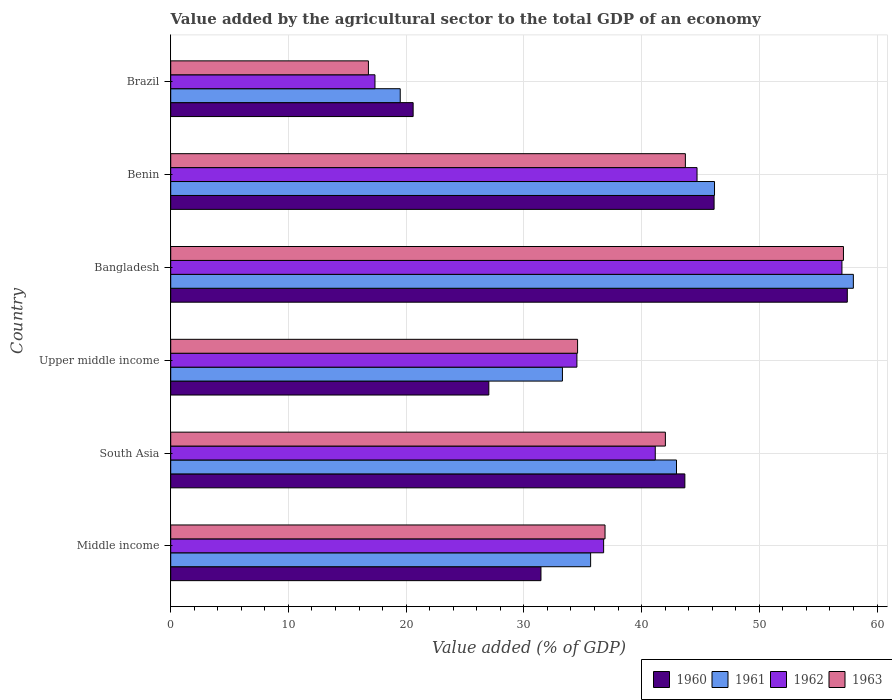How many groups of bars are there?
Offer a terse response. 6. How many bars are there on the 3rd tick from the top?
Your answer should be compact. 4. How many bars are there on the 6th tick from the bottom?
Your answer should be compact. 4. What is the label of the 2nd group of bars from the top?
Provide a short and direct response. Benin. What is the value added by the agricultural sector to the total GDP in 1963 in Upper middle income?
Your response must be concise. 34.56. Across all countries, what is the maximum value added by the agricultural sector to the total GDP in 1961?
Your answer should be very brief. 57.99. Across all countries, what is the minimum value added by the agricultural sector to the total GDP in 1963?
Ensure brevity in your answer.  16.79. What is the total value added by the agricultural sector to the total GDP in 1960 in the graph?
Your answer should be compact. 226.37. What is the difference between the value added by the agricultural sector to the total GDP in 1963 in Benin and that in Upper middle income?
Your answer should be compact. 9.16. What is the difference between the value added by the agricultural sector to the total GDP in 1960 in Benin and the value added by the agricultural sector to the total GDP in 1962 in Upper middle income?
Provide a short and direct response. 11.65. What is the average value added by the agricultural sector to the total GDP in 1961 per country?
Make the answer very short. 39.26. What is the difference between the value added by the agricultural sector to the total GDP in 1960 and value added by the agricultural sector to the total GDP in 1961 in Middle income?
Ensure brevity in your answer.  -4.22. What is the ratio of the value added by the agricultural sector to the total GDP in 1960 in Bangladesh to that in Upper middle income?
Give a very brief answer. 2.13. Is the value added by the agricultural sector to the total GDP in 1962 in Middle income less than that in Upper middle income?
Provide a succinct answer. No. Is the difference between the value added by the agricultural sector to the total GDP in 1960 in Benin and Brazil greater than the difference between the value added by the agricultural sector to the total GDP in 1961 in Benin and Brazil?
Provide a short and direct response. No. What is the difference between the highest and the second highest value added by the agricultural sector to the total GDP in 1961?
Your answer should be very brief. 11.79. What is the difference between the highest and the lowest value added by the agricultural sector to the total GDP in 1961?
Provide a short and direct response. 38.49. Is the sum of the value added by the agricultural sector to the total GDP in 1961 in Middle income and Upper middle income greater than the maximum value added by the agricultural sector to the total GDP in 1962 across all countries?
Offer a very short reply. Yes. What does the 3rd bar from the top in Middle income represents?
Make the answer very short. 1961. How many bars are there?
Your answer should be very brief. 24. How many countries are there in the graph?
Your response must be concise. 6. Are the values on the major ticks of X-axis written in scientific E-notation?
Offer a terse response. No. Does the graph contain grids?
Your answer should be compact. Yes. What is the title of the graph?
Make the answer very short. Value added by the agricultural sector to the total GDP of an economy. What is the label or title of the X-axis?
Offer a terse response. Value added (% of GDP). What is the Value added (% of GDP) in 1960 in Middle income?
Make the answer very short. 31.45. What is the Value added (% of GDP) in 1961 in Middle income?
Provide a short and direct response. 35.67. What is the Value added (% of GDP) in 1962 in Middle income?
Provide a succinct answer. 36.77. What is the Value added (% of GDP) of 1963 in Middle income?
Your response must be concise. 36.89. What is the Value added (% of GDP) of 1960 in South Asia?
Keep it short and to the point. 43.68. What is the Value added (% of GDP) of 1961 in South Asia?
Offer a terse response. 42.96. What is the Value added (% of GDP) of 1962 in South Asia?
Your answer should be compact. 41.16. What is the Value added (% of GDP) in 1963 in South Asia?
Your answer should be very brief. 42.02. What is the Value added (% of GDP) in 1960 in Upper middle income?
Your answer should be compact. 27.02. What is the Value added (% of GDP) in 1961 in Upper middle income?
Make the answer very short. 33.27. What is the Value added (% of GDP) of 1962 in Upper middle income?
Your answer should be very brief. 34.5. What is the Value added (% of GDP) of 1963 in Upper middle income?
Provide a succinct answer. 34.56. What is the Value added (% of GDP) in 1960 in Bangladesh?
Offer a very short reply. 57.47. What is the Value added (% of GDP) of 1961 in Bangladesh?
Offer a terse response. 57.99. What is the Value added (% of GDP) in 1962 in Bangladesh?
Give a very brief answer. 57.02. What is the Value added (% of GDP) of 1963 in Bangladesh?
Offer a very short reply. 57.15. What is the Value added (% of GDP) of 1960 in Benin?
Make the answer very short. 46.16. What is the Value added (% of GDP) of 1961 in Benin?
Make the answer very short. 46.19. What is the Value added (% of GDP) of 1962 in Benin?
Your answer should be compact. 44.71. What is the Value added (% of GDP) in 1963 in Benin?
Give a very brief answer. 43.72. What is the Value added (% of GDP) in 1960 in Brazil?
Your response must be concise. 20.59. What is the Value added (% of GDP) in 1961 in Brazil?
Offer a terse response. 19.5. What is the Value added (% of GDP) of 1962 in Brazil?
Keep it short and to the point. 17.35. What is the Value added (% of GDP) in 1963 in Brazil?
Ensure brevity in your answer.  16.79. Across all countries, what is the maximum Value added (% of GDP) of 1960?
Keep it short and to the point. 57.47. Across all countries, what is the maximum Value added (% of GDP) of 1961?
Your answer should be compact. 57.99. Across all countries, what is the maximum Value added (% of GDP) of 1962?
Offer a very short reply. 57.02. Across all countries, what is the maximum Value added (% of GDP) in 1963?
Ensure brevity in your answer.  57.15. Across all countries, what is the minimum Value added (% of GDP) in 1960?
Your answer should be compact. 20.59. Across all countries, what is the minimum Value added (% of GDP) in 1961?
Offer a terse response. 19.5. Across all countries, what is the minimum Value added (% of GDP) in 1962?
Your answer should be very brief. 17.35. Across all countries, what is the minimum Value added (% of GDP) in 1963?
Make the answer very short. 16.79. What is the total Value added (% of GDP) in 1960 in the graph?
Keep it short and to the point. 226.37. What is the total Value added (% of GDP) of 1961 in the graph?
Offer a terse response. 235.59. What is the total Value added (% of GDP) in 1962 in the graph?
Offer a terse response. 231.52. What is the total Value added (% of GDP) in 1963 in the graph?
Provide a succinct answer. 231.13. What is the difference between the Value added (% of GDP) in 1960 in Middle income and that in South Asia?
Offer a very short reply. -12.22. What is the difference between the Value added (% of GDP) of 1961 in Middle income and that in South Asia?
Provide a succinct answer. -7.29. What is the difference between the Value added (% of GDP) in 1962 in Middle income and that in South Asia?
Offer a very short reply. -4.39. What is the difference between the Value added (% of GDP) in 1963 in Middle income and that in South Asia?
Offer a terse response. -5.13. What is the difference between the Value added (% of GDP) in 1960 in Middle income and that in Upper middle income?
Your response must be concise. 4.43. What is the difference between the Value added (% of GDP) in 1961 in Middle income and that in Upper middle income?
Provide a short and direct response. 2.4. What is the difference between the Value added (% of GDP) in 1962 in Middle income and that in Upper middle income?
Provide a short and direct response. 2.27. What is the difference between the Value added (% of GDP) in 1963 in Middle income and that in Upper middle income?
Your answer should be compact. 2.33. What is the difference between the Value added (% of GDP) of 1960 in Middle income and that in Bangladesh?
Your answer should be very brief. -26.02. What is the difference between the Value added (% of GDP) of 1961 in Middle income and that in Bangladesh?
Your answer should be compact. -22.32. What is the difference between the Value added (% of GDP) of 1962 in Middle income and that in Bangladesh?
Provide a short and direct response. -20.24. What is the difference between the Value added (% of GDP) of 1963 in Middle income and that in Bangladesh?
Provide a succinct answer. -20.25. What is the difference between the Value added (% of GDP) of 1960 in Middle income and that in Benin?
Provide a succinct answer. -14.71. What is the difference between the Value added (% of GDP) of 1961 in Middle income and that in Benin?
Offer a terse response. -10.52. What is the difference between the Value added (% of GDP) in 1962 in Middle income and that in Benin?
Offer a very short reply. -7.94. What is the difference between the Value added (% of GDP) of 1963 in Middle income and that in Benin?
Make the answer very short. -6.82. What is the difference between the Value added (% of GDP) in 1960 in Middle income and that in Brazil?
Make the answer very short. 10.86. What is the difference between the Value added (% of GDP) in 1961 in Middle income and that in Brazil?
Offer a very short reply. 16.17. What is the difference between the Value added (% of GDP) in 1962 in Middle income and that in Brazil?
Provide a succinct answer. 19.42. What is the difference between the Value added (% of GDP) in 1963 in Middle income and that in Brazil?
Give a very brief answer. 20.1. What is the difference between the Value added (% of GDP) in 1960 in South Asia and that in Upper middle income?
Offer a terse response. 16.65. What is the difference between the Value added (% of GDP) in 1961 in South Asia and that in Upper middle income?
Make the answer very short. 9.69. What is the difference between the Value added (% of GDP) of 1962 in South Asia and that in Upper middle income?
Offer a terse response. 6.66. What is the difference between the Value added (% of GDP) of 1963 in South Asia and that in Upper middle income?
Give a very brief answer. 7.46. What is the difference between the Value added (% of GDP) of 1960 in South Asia and that in Bangladesh?
Offer a very short reply. -13.8. What is the difference between the Value added (% of GDP) of 1961 in South Asia and that in Bangladesh?
Keep it short and to the point. -15.02. What is the difference between the Value added (% of GDP) in 1962 in South Asia and that in Bangladesh?
Offer a terse response. -15.86. What is the difference between the Value added (% of GDP) of 1963 in South Asia and that in Bangladesh?
Provide a short and direct response. -15.13. What is the difference between the Value added (% of GDP) of 1960 in South Asia and that in Benin?
Your answer should be compact. -2.48. What is the difference between the Value added (% of GDP) of 1961 in South Asia and that in Benin?
Ensure brevity in your answer.  -3.23. What is the difference between the Value added (% of GDP) in 1962 in South Asia and that in Benin?
Offer a terse response. -3.55. What is the difference between the Value added (% of GDP) of 1963 in South Asia and that in Benin?
Offer a terse response. -1.7. What is the difference between the Value added (% of GDP) in 1960 in South Asia and that in Brazil?
Offer a terse response. 23.08. What is the difference between the Value added (% of GDP) in 1961 in South Asia and that in Brazil?
Give a very brief answer. 23.47. What is the difference between the Value added (% of GDP) in 1962 in South Asia and that in Brazil?
Give a very brief answer. 23.81. What is the difference between the Value added (% of GDP) in 1963 in South Asia and that in Brazil?
Provide a short and direct response. 25.23. What is the difference between the Value added (% of GDP) of 1960 in Upper middle income and that in Bangladesh?
Your answer should be very brief. -30.45. What is the difference between the Value added (% of GDP) of 1961 in Upper middle income and that in Bangladesh?
Provide a short and direct response. -24.71. What is the difference between the Value added (% of GDP) of 1962 in Upper middle income and that in Bangladesh?
Provide a short and direct response. -22.51. What is the difference between the Value added (% of GDP) in 1963 in Upper middle income and that in Bangladesh?
Your answer should be compact. -22.59. What is the difference between the Value added (% of GDP) of 1960 in Upper middle income and that in Benin?
Offer a very short reply. -19.14. What is the difference between the Value added (% of GDP) in 1961 in Upper middle income and that in Benin?
Provide a short and direct response. -12.92. What is the difference between the Value added (% of GDP) of 1962 in Upper middle income and that in Benin?
Offer a very short reply. -10.21. What is the difference between the Value added (% of GDP) of 1963 in Upper middle income and that in Benin?
Offer a very short reply. -9.16. What is the difference between the Value added (% of GDP) in 1960 in Upper middle income and that in Brazil?
Your response must be concise. 6.43. What is the difference between the Value added (% of GDP) in 1961 in Upper middle income and that in Brazil?
Provide a short and direct response. 13.78. What is the difference between the Value added (% of GDP) in 1962 in Upper middle income and that in Brazil?
Provide a succinct answer. 17.15. What is the difference between the Value added (% of GDP) of 1963 in Upper middle income and that in Brazil?
Offer a terse response. 17.77. What is the difference between the Value added (% of GDP) of 1960 in Bangladesh and that in Benin?
Offer a very short reply. 11.32. What is the difference between the Value added (% of GDP) of 1961 in Bangladesh and that in Benin?
Ensure brevity in your answer.  11.79. What is the difference between the Value added (% of GDP) of 1962 in Bangladesh and that in Benin?
Ensure brevity in your answer.  12.31. What is the difference between the Value added (% of GDP) in 1963 in Bangladesh and that in Benin?
Your response must be concise. 13.43. What is the difference between the Value added (% of GDP) in 1960 in Bangladesh and that in Brazil?
Make the answer very short. 36.88. What is the difference between the Value added (% of GDP) of 1961 in Bangladesh and that in Brazil?
Your response must be concise. 38.49. What is the difference between the Value added (% of GDP) in 1962 in Bangladesh and that in Brazil?
Provide a short and direct response. 39.67. What is the difference between the Value added (% of GDP) of 1963 in Bangladesh and that in Brazil?
Your answer should be very brief. 40.35. What is the difference between the Value added (% of GDP) of 1960 in Benin and that in Brazil?
Provide a succinct answer. 25.56. What is the difference between the Value added (% of GDP) in 1961 in Benin and that in Brazil?
Offer a very short reply. 26.7. What is the difference between the Value added (% of GDP) of 1962 in Benin and that in Brazil?
Your answer should be very brief. 27.36. What is the difference between the Value added (% of GDP) in 1963 in Benin and that in Brazil?
Your answer should be compact. 26.92. What is the difference between the Value added (% of GDP) of 1960 in Middle income and the Value added (% of GDP) of 1961 in South Asia?
Ensure brevity in your answer.  -11.51. What is the difference between the Value added (% of GDP) in 1960 in Middle income and the Value added (% of GDP) in 1962 in South Asia?
Provide a succinct answer. -9.71. What is the difference between the Value added (% of GDP) of 1960 in Middle income and the Value added (% of GDP) of 1963 in South Asia?
Make the answer very short. -10.57. What is the difference between the Value added (% of GDP) in 1961 in Middle income and the Value added (% of GDP) in 1962 in South Asia?
Make the answer very short. -5.49. What is the difference between the Value added (% of GDP) in 1961 in Middle income and the Value added (% of GDP) in 1963 in South Asia?
Make the answer very short. -6.35. What is the difference between the Value added (% of GDP) in 1962 in Middle income and the Value added (% of GDP) in 1963 in South Asia?
Offer a terse response. -5.25. What is the difference between the Value added (% of GDP) in 1960 in Middle income and the Value added (% of GDP) in 1961 in Upper middle income?
Your answer should be compact. -1.82. What is the difference between the Value added (% of GDP) in 1960 in Middle income and the Value added (% of GDP) in 1962 in Upper middle income?
Provide a short and direct response. -3.05. What is the difference between the Value added (% of GDP) in 1960 in Middle income and the Value added (% of GDP) in 1963 in Upper middle income?
Your answer should be very brief. -3.11. What is the difference between the Value added (% of GDP) of 1961 in Middle income and the Value added (% of GDP) of 1962 in Upper middle income?
Provide a short and direct response. 1.17. What is the difference between the Value added (% of GDP) in 1961 in Middle income and the Value added (% of GDP) in 1963 in Upper middle income?
Keep it short and to the point. 1.11. What is the difference between the Value added (% of GDP) of 1962 in Middle income and the Value added (% of GDP) of 1963 in Upper middle income?
Make the answer very short. 2.21. What is the difference between the Value added (% of GDP) in 1960 in Middle income and the Value added (% of GDP) in 1961 in Bangladesh?
Offer a terse response. -26.54. What is the difference between the Value added (% of GDP) of 1960 in Middle income and the Value added (% of GDP) of 1962 in Bangladesh?
Your answer should be compact. -25.57. What is the difference between the Value added (% of GDP) in 1960 in Middle income and the Value added (% of GDP) in 1963 in Bangladesh?
Your answer should be compact. -25.7. What is the difference between the Value added (% of GDP) of 1961 in Middle income and the Value added (% of GDP) of 1962 in Bangladesh?
Your answer should be compact. -21.35. What is the difference between the Value added (% of GDP) of 1961 in Middle income and the Value added (% of GDP) of 1963 in Bangladesh?
Offer a terse response. -21.48. What is the difference between the Value added (% of GDP) in 1962 in Middle income and the Value added (% of GDP) in 1963 in Bangladesh?
Your answer should be compact. -20.37. What is the difference between the Value added (% of GDP) of 1960 in Middle income and the Value added (% of GDP) of 1961 in Benin?
Keep it short and to the point. -14.74. What is the difference between the Value added (% of GDP) of 1960 in Middle income and the Value added (% of GDP) of 1962 in Benin?
Provide a short and direct response. -13.26. What is the difference between the Value added (% of GDP) in 1960 in Middle income and the Value added (% of GDP) in 1963 in Benin?
Provide a short and direct response. -12.27. What is the difference between the Value added (% of GDP) in 1961 in Middle income and the Value added (% of GDP) in 1962 in Benin?
Offer a very short reply. -9.04. What is the difference between the Value added (% of GDP) of 1961 in Middle income and the Value added (% of GDP) of 1963 in Benin?
Offer a terse response. -8.05. What is the difference between the Value added (% of GDP) of 1962 in Middle income and the Value added (% of GDP) of 1963 in Benin?
Provide a short and direct response. -6.94. What is the difference between the Value added (% of GDP) of 1960 in Middle income and the Value added (% of GDP) of 1961 in Brazil?
Your answer should be compact. 11.95. What is the difference between the Value added (% of GDP) in 1960 in Middle income and the Value added (% of GDP) in 1962 in Brazil?
Your answer should be very brief. 14.1. What is the difference between the Value added (% of GDP) in 1960 in Middle income and the Value added (% of GDP) in 1963 in Brazil?
Ensure brevity in your answer.  14.66. What is the difference between the Value added (% of GDP) in 1961 in Middle income and the Value added (% of GDP) in 1962 in Brazil?
Your response must be concise. 18.32. What is the difference between the Value added (% of GDP) in 1961 in Middle income and the Value added (% of GDP) in 1963 in Brazil?
Give a very brief answer. 18.88. What is the difference between the Value added (% of GDP) of 1962 in Middle income and the Value added (% of GDP) of 1963 in Brazil?
Your answer should be compact. 19.98. What is the difference between the Value added (% of GDP) in 1960 in South Asia and the Value added (% of GDP) in 1961 in Upper middle income?
Offer a very short reply. 10.4. What is the difference between the Value added (% of GDP) of 1960 in South Asia and the Value added (% of GDP) of 1962 in Upper middle income?
Keep it short and to the point. 9.17. What is the difference between the Value added (% of GDP) of 1960 in South Asia and the Value added (% of GDP) of 1963 in Upper middle income?
Your answer should be very brief. 9.11. What is the difference between the Value added (% of GDP) in 1961 in South Asia and the Value added (% of GDP) in 1962 in Upper middle income?
Ensure brevity in your answer.  8.46. What is the difference between the Value added (% of GDP) in 1961 in South Asia and the Value added (% of GDP) in 1963 in Upper middle income?
Offer a very short reply. 8.4. What is the difference between the Value added (% of GDP) of 1962 in South Asia and the Value added (% of GDP) of 1963 in Upper middle income?
Ensure brevity in your answer.  6.6. What is the difference between the Value added (% of GDP) in 1960 in South Asia and the Value added (% of GDP) in 1961 in Bangladesh?
Make the answer very short. -14.31. What is the difference between the Value added (% of GDP) of 1960 in South Asia and the Value added (% of GDP) of 1962 in Bangladesh?
Provide a short and direct response. -13.34. What is the difference between the Value added (% of GDP) in 1960 in South Asia and the Value added (% of GDP) in 1963 in Bangladesh?
Your response must be concise. -13.47. What is the difference between the Value added (% of GDP) of 1961 in South Asia and the Value added (% of GDP) of 1962 in Bangladesh?
Keep it short and to the point. -14.05. What is the difference between the Value added (% of GDP) in 1961 in South Asia and the Value added (% of GDP) in 1963 in Bangladesh?
Make the answer very short. -14.18. What is the difference between the Value added (% of GDP) of 1962 in South Asia and the Value added (% of GDP) of 1963 in Bangladesh?
Give a very brief answer. -15.99. What is the difference between the Value added (% of GDP) of 1960 in South Asia and the Value added (% of GDP) of 1961 in Benin?
Offer a terse response. -2.52. What is the difference between the Value added (% of GDP) in 1960 in South Asia and the Value added (% of GDP) in 1962 in Benin?
Offer a very short reply. -1.03. What is the difference between the Value added (% of GDP) in 1960 in South Asia and the Value added (% of GDP) in 1963 in Benin?
Ensure brevity in your answer.  -0.04. What is the difference between the Value added (% of GDP) of 1961 in South Asia and the Value added (% of GDP) of 1962 in Benin?
Give a very brief answer. -1.74. What is the difference between the Value added (% of GDP) in 1961 in South Asia and the Value added (% of GDP) in 1963 in Benin?
Your answer should be very brief. -0.75. What is the difference between the Value added (% of GDP) in 1962 in South Asia and the Value added (% of GDP) in 1963 in Benin?
Give a very brief answer. -2.56. What is the difference between the Value added (% of GDP) of 1960 in South Asia and the Value added (% of GDP) of 1961 in Brazil?
Your answer should be compact. 24.18. What is the difference between the Value added (% of GDP) in 1960 in South Asia and the Value added (% of GDP) in 1962 in Brazil?
Your response must be concise. 26.32. What is the difference between the Value added (% of GDP) of 1960 in South Asia and the Value added (% of GDP) of 1963 in Brazil?
Your response must be concise. 26.88. What is the difference between the Value added (% of GDP) of 1961 in South Asia and the Value added (% of GDP) of 1962 in Brazil?
Your answer should be very brief. 25.61. What is the difference between the Value added (% of GDP) in 1961 in South Asia and the Value added (% of GDP) in 1963 in Brazil?
Make the answer very short. 26.17. What is the difference between the Value added (% of GDP) in 1962 in South Asia and the Value added (% of GDP) in 1963 in Brazil?
Offer a terse response. 24.37. What is the difference between the Value added (% of GDP) of 1960 in Upper middle income and the Value added (% of GDP) of 1961 in Bangladesh?
Your response must be concise. -30.97. What is the difference between the Value added (% of GDP) in 1960 in Upper middle income and the Value added (% of GDP) in 1962 in Bangladesh?
Ensure brevity in your answer.  -30. What is the difference between the Value added (% of GDP) in 1960 in Upper middle income and the Value added (% of GDP) in 1963 in Bangladesh?
Provide a short and direct response. -30.12. What is the difference between the Value added (% of GDP) of 1961 in Upper middle income and the Value added (% of GDP) of 1962 in Bangladesh?
Give a very brief answer. -23.74. What is the difference between the Value added (% of GDP) of 1961 in Upper middle income and the Value added (% of GDP) of 1963 in Bangladesh?
Make the answer very short. -23.87. What is the difference between the Value added (% of GDP) in 1962 in Upper middle income and the Value added (% of GDP) in 1963 in Bangladesh?
Ensure brevity in your answer.  -22.64. What is the difference between the Value added (% of GDP) in 1960 in Upper middle income and the Value added (% of GDP) in 1961 in Benin?
Ensure brevity in your answer.  -19.17. What is the difference between the Value added (% of GDP) of 1960 in Upper middle income and the Value added (% of GDP) of 1962 in Benin?
Your answer should be compact. -17.69. What is the difference between the Value added (% of GDP) of 1960 in Upper middle income and the Value added (% of GDP) of 1963 in Benin?
Offer a terse response. -16.7. What is the difference between the Value added (% of GDP) in 1961 in Upper middle income and the Value added (% of GDP) in 1962 in Benin?
Offer a very short reply. -11.43. What is the difference between the Value added (% of GDP) of 1961 in Upper middle income and the Value added (% of GDP) of 1963 in Benin?
Offer a very short reply. -10.44. What is the difference between the Value added (% of GDP) of 1962 in Upper middle income and the Value added (% of GDP) of 1963 in Benin?
Give a very brief answer. -9.21. What is the difference between the Value added (% of GDP) in 1960 in Upper middle income and the Value added (% of GDP) in 1961 in Brazil?
Your response must be concise. 7.53. What is the difference between the Value added (% of GDP) in 1960 in Upper middle income and the Value added (% of GDP) in 1962 in Brazil?
Keep it short and to the point. 9.67. What is the difference between the Value added (% of GDP) in 1960 in Upper middle income and the Value added (% of GDP) in 1963 in Brazil?
Offer a very short reply. 10.23. What is the difference between the Value added (% of GDP) of 1961 in Upper middle income and the Value added (% of GDP) of 1962 in Brazil?
Your answer should be compact. 15.92. What is the difference between the Value added (% of GDP) in 1961 in Upper middle income and the Value added (% of GDP) in 1963 in Brazil?
Offer a very short reply. 16.48. What is the difference between the Value added (% of GDP) in 1962 in Upper middle income and the Value added (% of GDP) in 1963 in Brazil?
Offer a very short reply. 17.71. What is the difference between the Value added (% of GDP) of 1960 in Bangladesh and the Value added (% of GDP) of 1961 in Benin?
Provide a succinct answer. 11.28. What is the difference between the Value added (% of GDP) in 1960 in Bangladesh and the Value added (% of GDP) in 1962 in Benin?
Offer a very short reply. 12.77. What is the difference between the Value added (% of GDP) in 1960 in Bangladesh and the Value added (% of GDP) in 1963 in Benin?
Your response must be concise. 13.76. What is the difference between the Value added (% of GDP) of 1961 in Bangladesh and the Value added (% of GDP) of 1962 in Benin?
Ensure brevity in your answer.  13.28. What is the difference between the Value added (% of GDP) in 1961 in Bangladesh and the Value added (% of GDP) in 1963 in Benin?
Give a very brief answer. 14.27. What is the difference between the Value added (% of GDP) of 1962 in Bangladesh and the Value added (% of GDP) of 1963 in Benin?
Provide a succinct answer. 13.3. What is the difference between the Value added (% of GDP) of 1960 in Bangladesh and the Value added (% of GDP) of 1961 in Brazil?
Your answer should be very brief. 37.98. What is the difference between the Value added (% of GDP) of 1960 in Bangladesh and the Value added (% of GDP) of 1962 in Brazil?
Offer a very short reply. 40.12. What is the difference between the Value added (% of GDP) in 1960 in Bangladesh and the Value added (% of GDP) in 1963 in Brazil?
Give a very brief answer. 40.68. What is the difference between the Value added (% of GDP) of 1961 in Bangladesh and the Value added (% of GDP) of 1962 in Brazil?
Give a very brief answer. 40.64. What is the difference between the Value added (% of GDP) of 1961 in Bangladesh and the Value added (% of GDP) of 1963 in Brazil?
Keep it short and to the point. 41.19. What is the difference between the Value added (% of GDP) of 1962 in Bangladesh and the Value added (% of GDP) of 1963 in Brazil?
Your answer should be very brief. 40.22. What is the difference between the Value added (% of GDP) in 1960 in Benin and the Value added (% of GDP) in 1961 in Brazil?
Your answer should be compact. 26.66. What is the difference between the Value added (% of GDP) in 1960 in Benin and the Value added (% of GDP) in 1962 in Brazil?
Offer a very short reply. 28.81. What is the difference between the Value added (% of GDP) of 1960 in Benin and the Value added (% of GDP) of 1963 in Brazil?
Make the answer very short. 29.36. What is the difference between the Value added (% of GDP) in 1961 in Benin and the Value added (% of GDP) in 1962 in Brazil?
Offer a terse response. 28.84. What is the difference between the Value added (% of GDP) of 1961 in Benin and the Value added (% of GDP) of 1963 in Brazil?
Offer a terse response. 29.4. What is the difference between the Value added (% of GDP) of 1962 in Benin and the Value added (% of GDP) of 1963 in Brazil?
Your response must be concise. 27.92. What is the average Value added (% of GDP) of 1960 per country?
Offer a terse response. 37.73. What is the average Value added (% of GDP) of 1961 per country?
Offer a terse response. 39.26. What is the average Value added (% of GDP) of 1962 per country?
Ensure brevity in your answer.  38.59. What is the average Value added (% of GDP) in 1963 per country?
Ensure brevity in your answer.  38.52. What is the difference between the Value added (% of GDP) of 1960 and Value added (% of GDP) of 1961 in Middle income?
Ensure brevity in your answer.  -4.22. What is the difference between the Value added (% of GDP) of 1960 and Value added (% of GDP) of 1962 in Middle income?
Provide a short and direct response. -5.32. What is the difference between the Value added (% of GDP) of 1960 and Value added (% of GDP) of 1963 in Middle income?
Offer a very short reply. -5.44. What is the difference between the Value added (% of GDP) of 1961 and Value added (% of GDP) of 1962 in Middle income?
Ensure brevity in your answer.  -1.1. What is the difference between the Value added (% of GDP) in 1961 and Value added (% of GDP) in 1963 in Middle income?
Keep it short and to the point. -1.22. What is the difference between the Value added (% of GDP) in 1962 and Value added (% of GDP) in 1963 in Middle income?
Your answer should be very brief. -0.12. What is the difference between the Value added (% of GDP) in 1960 and Value added (% of GDP) in 1961 in South Asia?
Give a very brief answer. 0.71. What is the difference between the Value added (% of GDP) in 1960 and Value added (% of GDP) in 1962 in South Asia?
Provide a succinct answer. 2.52. What is the difference between the Value added (% of GDP) of 1960 and Value added (% of GDP) of 1963 in South Asia?
Make the answer very short. 1.66. What is the difference between the Value added (% of GDP) in 1961 and Value added (% of GDP) in 1962 in South Asia?
Provide a succinct answer. 1.8. What is the difference between the Value added (% of GDP) of 1961 and Value added (% of GDP) of 1963 in South Asia?
Provide a short and direct response. 0.95. What is the difference between the Value added (% of GDP) of 1962 and Value added (% of GDP) of 1963 in South Asia?
Keep it short and to the point. -0.86. What is the difference between the Value added (% of GDP) in 1960 and Value added (% of GDP) in 1961 in Upper middle income?
Make the answer very short. -6.25. What is the difference between the Value added (% of GDP) in 1960 and Value added (% of GDP) in 1962 in Upper middle income?
Offer a very short reply. -7.48. What is the difference between the Value added (% of GDP) of 1960 and Value added (% of GDP) of 1963 in Upper middle income?
Make the answer very short. -7.54. What is the difference between the Value added (% of GDP) in 1961 and Value added (% of GDP) in 1962 in Upper middle income?
Keep it short and to the point. -1.23. What is the difference between the Value added (% of GDP) of 1961 and Value added (% of GDP) of 1963 in Upper middle income?
Provide a succinct answer. -1.29. What is the difference between the Value added (% of GDP) in 1962 and Value added (% of GDP) in 1963 in Upper middle income?
Keep it short and to the point. -0.06. What is the difference between the Value added (% of GDP) in 1960 and Value added (% of GDP) in 1961 in Bangladesh?
Provide a succinct answer. -0.51. What is the difference between the Value added (% of GDP) of 1960 and Value added (% of GDP) of 1962 in Bangladesh?
Provide a succinct answer. 0.46. What is the difference between the Value added (% of GDP) in 1960 and Value added (% of GDP) in 1963 in Bangladesh?
Offer a terse response. 0.33. What is the difference between the Value added (% of GDP) of 1961 and Value added (% of GDP) of 1962 in Bangladesh?
Ensure brevity in your answer.  0.97. What is the difference between the Value added (% of GDP) in 1961 and Value added (% of GDP) in 1963 in Bangladesh?
Your answer should be compact. 0.84. What is the difference between the Value added (% of GDP) of 1962 and Value added (% of GDP) of 1963 in Bangladesh?
Make the answer very short. -0.13. What is the difference between the Value added (% of GDP) of 1960 and Value added (% of GDP) of 1961 in Benin?
Offer a very short reply. -0.04. What is the difference between the Value added (% of GDP) in 1960 and Value added (% of GDP) in 1962 in Benin?
Your answer should be compact. 1.45. What is the difference between the Value added (% of GDP) of 1960 and Value added (% of GDP) of 1963 in Benin?
Your answer should be very brief. 2.44. What is the difference between the Value added (% of GDP) in 1961 and Value added (% of GDP) in 1962 in Benin?
Provide a short and direct response. 1.48. What is the difference between the Value added (% of GDP) of 1961 and Value added (% of GDP) of 1963 in Benin?
Keep it short and to the point. 2.48. What is the difference between the Value added (% of GDP) of 1962 and Value added (% of GDP) of 1963 in Benin?
Provide a short and direct response. 0.99. What is the difference between the Value added (% of GDP) in 1960 and Value added (% of GDP) in 1961 in Brazil?
Provide a succinct answer. 1.1. What is the difference between the Value added (% of GDP) of 1960 and Value added (% of GDP) of 1962 in Brazil?
Your answer should be very brief. 3.24. What is the difference between the Value added (% of GDP) in 1960 and Value added (% of GDP) in 1963 in Brazil?
Make the answer very short. 3.8. What is the difference between the Value added (% of GDP) in 1961 and Value added (% of GDP) in 1962 in Brazil?
Provide a short and direct response. 2.15. What is the difference between the Value added (% of GDP) in 1961 and Value added (% of GDP) in 1963 in Brazil?
Your answer should be very brief. 2.7. What is the difference between the Value added (% of GDP) in 1962 and Value added (% of GDP) in 1963 in Brazil?
Offer a very short reply. 0.56. What is the ratio of the Value added (% of GDP) in 1960 in Middle income to that in South Asia?
Provide a succinct answer. 0.72. What is the ratio of the Value added (% of GDP) of 1961 in Middle income to that in South Asia?
Provide a succinct answer. 0.83. What is the ratio of the Value added (% of GDP) of 1962 in Middle income to that in South Asia?
Offer a very short reply. 0.89. What is the ratio of the Value added (% of GDP) in 1963 in Middle income to that in South Asia?
Give a very brief answer. 0.88. What is the ratio of the Value added (% of GDP) of 1960 in Middle income to that in Upper middle income?
Keep it short and to the point. 1.16. What is the ratio of the Value added (% of GDP) of 1961 in Middle income to that in Upper middle income?
Offer a terse response. 1.07. What is the ratio of the Value added (% of GDP) in 1962 in Middle income to that in Upper middle income?
Your response must be concise. 1.07. What is the ratio of the Value added (% of GDP) in 1963 in Middle income to that in Upper middle income?
Your response must be concise. 1.07. What is the ratio of the Value added (% of GDP) in 1960 in Middle income to that in Bangladesh?
Provide a succinct answer. 0.55. What is the ratio of the Value added (% of GDP) in 1961 in Middle income to that in Bangladesh?
Ensure brevity in your answer.  0.62. What is the ratio of the Value added (% of GDP) in 1962 in Middle income to that in Bangladesh?
Give a very brief answer. 0.64. What is the ratio of the Value added (% of GDP) of 1963 in Middle income to that in Bangladesh?
Keep it short and to the point. 0.65. What is the ratio of the Value added (% of GDP) in 1960 in Middle income to that in Benin?
Your response must be concise. 0.68. What is the ratio of the Value added (% of GDP) of 1961 in Middle income to that in Benin?
Provide a succinct answer. 0.77. What is the ratio of the Value added (% of GDP) of 1962 in Middle income to that in Benin?
Offer a terse response. 0.82. What is the ratio of the Value added (% of GDP) in 1963 in Middle income to that in Benin?
Provide a short and direct response. 0.84. What is the ratio of the Value added (% of GDP) of 1960 in Middle income to that in Brazil?
Ensure brevity in your answer.  1.53. What is the ratio of the Value added (% of GDP) of 1961 in Middle income to that in Brazil?
Provide a short and direct response. 1.83. What is the ratio of the Value added (% of GDP) in 1962 in Middle income to that in Brazil?
Keep it short and to the point. 2.12. What is the ratio of the Value added (% of GDP) in 1963 in Middle income to that in Brazil?
Offer a very short reply. 2.2. What is the ratio of the Value added (% of GDP) in 1960 in South Asia to that in Upper middle income?
Your answer should be very brief. 1.62. What is the ratio of the Value added (% of GDP) in 1961 in South Asia to that in Upper middle income?
Your answer should be very brief. 1.29. What is the ratio of the Value added (% of GDP) of 1962 in South Asia to that in Upper middle income?
Your response must be concise. 1.19. What is the ratio of the Value added (% of GDP) of 1963 in South Asia to that in Upper middle income?
Make the answer very short. 1.22. What is the ratio of the Value added (% of GDP) of 1960 in South Asia to that in Bangladesh?
Provide a short and direct response. 0.76. What is the ratio of the Value added (% of GDP) in 1961 in South Asia to that in Bangladesh?
Give a very brief answer. 0.74. What is the ratio of the Value added (% of GDP) of 1962 in South Asia to that in Bangladesh?
Your answer should be very brief. 0.72. What is the ratio of the Value added (% of GDP) in 1963 in South Asia to that in Bangladesh?
Your answer should be compact. 0.74. What is the ratio of the Value added (% of GDP) of 1960 in South Asia to that in Benin?
Your answer should be very brief. 0.95. What is the ratio of the Value added (% of GDP) in 1961 in South Asia to that in Benin?
Give a very brief answer. 0.93. What is the ratio of the Value added (% of GDP) of 1962 in South Asia to that in Benin?
Keep it short and to the point. 0.92. What is the ratio of the Value added (% of GDP) of 1963 in South Asia to that in Benin?
Make the answer very short. 0.96. What is the ratio of the Value added (% of GDP) of 1960 in South Asia to that in Brazil?
Offer a terse response. 2.12. What is the ratio of the Value added (% of GDP) in 1961 in South Asia to that in Brazil?
Your answer should be very brief. 2.2. What is the ratio of the Value added (% of GDP) in 1962 in South Asia to that in Brazil?
Make the answer very short. 2.37. What is the ratio of the Value added (% of GDP) in 1963 in South Asia to that in Brazil?
Keep it short and to the point. 2.5. What is the ratio of the Value added (% of GDP) in 1960 in Upper middle income to that in Bangladesh?
Make the answer very short. 0.47. What is the ratio of the Value added (% of GDP) in 1961 in Upper middle income to that in Bangladesh?
Provide a short and direct response. 0.57. What is the ratio of the Value added (% of GDP) of 1962 in Upper middle income to that in Bangladesh?
Offer a terse response. 0.61. What is the ratio of the Value added (% of GDP) in 1963 in Upper middle income to that in Bangladesh?
Give a very brief answer. 0.6. What is the ratio of the Value added (% of GDP) of 1960 in Upper middle income to that in Benin?
Keep it short and to the point. 0.59. What is the ratio of the Value added (% of GDP) of 1961 in Upper middle income to that in Benin?
Make the answer very short. 0.72. What is the ratio of the Value added (% of GDP) of 1962 in Upper middle income to that in Benin?
Ensure brevity in your answer.  0.77. What is the ratio of the Value added (% of GDP) of 1963 in Upper middle income to that in Benin?
Give a very brief answer. 0.79. What is the ratio of the Value added (% of GDP) of 1960 in Upper middle income to that in Brazil?
Your answer should be compact. 1.31. What is the ratio of the Value added (% of GDP) in 1961 in Upper middle income to that in Brazil?
Give a very brief answer. 1.71. What is the ratio of the Value added (% of GDP) of 1962 in Upper middle income to that in Brazil?
Make the answer very short. 1.99. What is the ratio of the Value added (% of GDP) of 1963 in Upper middle income to that in Brazil?
Offer a very short reply. 2.06. What is the ratio of the Value added (% of GDP) of 1960 in Bangladesh to that in Benin?
Ensure brevity in your answer.  1.25. What is the ratio of the Value added (% of GDP) in 1961 in Bangladesh to that in Benin?
Give a very brief answer. 1.26. What is the ratio of the Value added (% of GDP) of 1962 in Bangladesh to that in Benin?
Offer a very short reply. 1.28. What is the ratio of the Value added (% of GDP) in 1963 in Bangladesh to that in Benin?
Provide a short and direct response. 1.31. What is the ratio of the Value added (% of GDP) of 1960 in Bangladesh to that in Brazil?
Provide a succinct answer. 2.79. What is the ratio of the Value added (% of GDP) in 1961 in Bangladesh to that in Brazil?
Provide a short and direct response. 2.97. What is the ratio of the Value added (% of GDP) of 1962 in Bangladesh to that in Brazil?
Your answer should be very brief. 3.29. What is the ratio of the Value added (% of GDP) of 1963 in Bangladesh to that in Brazil?
Provide a short and direct response. 3.4. What is the ratio of the Value added (% of GDP) in 1960 in Benin to that in Brazil?
Offer a very short reply. 2.24. What is the ratio of the Value added (% of GDP) of 1961 in Benin to that in Brazil?
Provide a short and direct response. 2.37. What is the ratio of the Value added (% of GDP) of 1962 in Benin to that in Brazil?
Keep it short and to the point. 2.58. What is the ratio of the Value added (% of GDP) in 1963 in Benin to that in Brazil?
Your answer should be compact. 2.6. What is the difference between the highest and the second highest Value added (% of GDP) of 1960?
Offer a terse response. 11.32. What is the difference between the highest and the second highest Value added (% of GDP) of 1961?
Give a very brief answer. 11.79. What is the difference between the highest and the second highest Value added (% of GDP) in 1962?
Keep it short and to the point. 12.31. What is the difference between the highest and the second highest Value added (% of GDP) in 1963?
Provide a short and direct response. 13.43. What is the difference between the highest and the lowest Value added (% of GDP) of 1960?
Your response must be concise. 36.88. What is the difference between the highest and the lowest Value added (% of GDP) in 1961?
Provide a succinct answer. 38.49. What is the difference between the highest and the lowest Value added (% of GDP) in 1962?
Provide a short and direct response. 39.67. What is the difference between the highest and the lowest Value added (% of GDP) in 1963?
Make the answer very short. 40.35. 